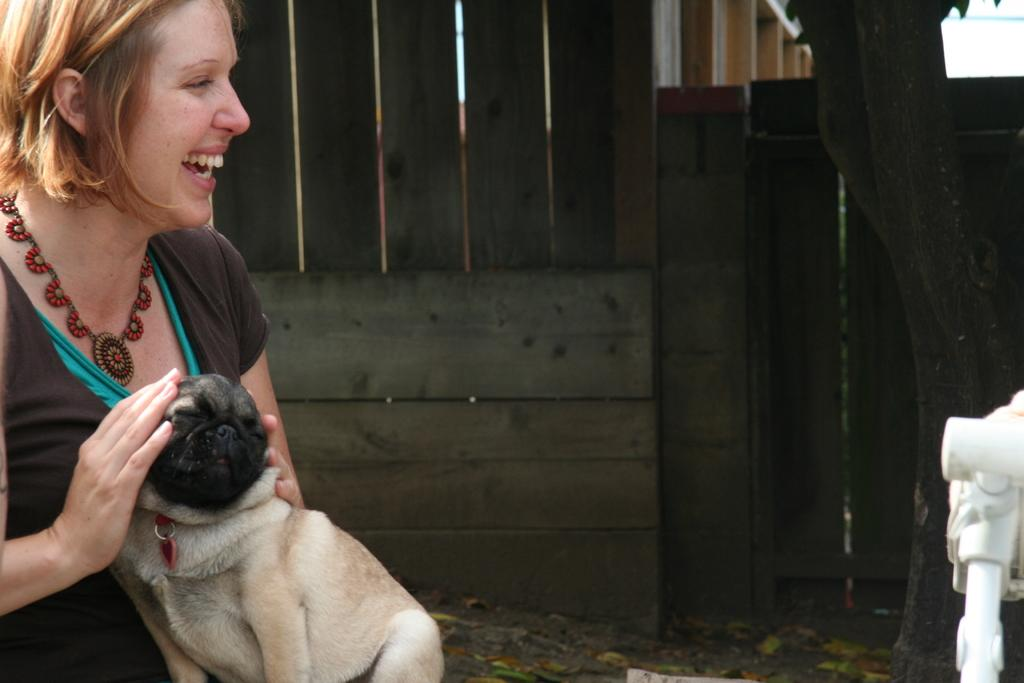Who is the main subject in the image? There is a woman in the image. What is the woman doing in the image? The woman is catching a dog in the image. How does the woman feel in the image? The woman is laughing in the image. What type of salt is being used to flavor the dog in the image? There is no salt or flavoring mentioned in the image; the woman is simply catching a dog and laughing. 